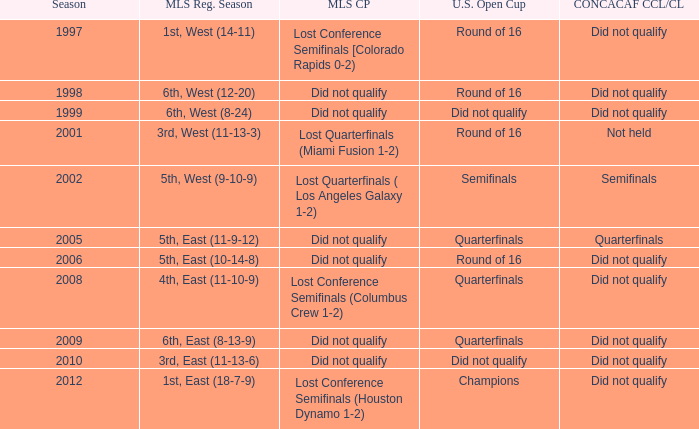What were the placements of the team in regular season when they reached quarterfinals in the U.S. Open Cup but did not qualify for the Concaf Champions Cup? 4th, East (11-10-9), 6th, East (8-13-9). 